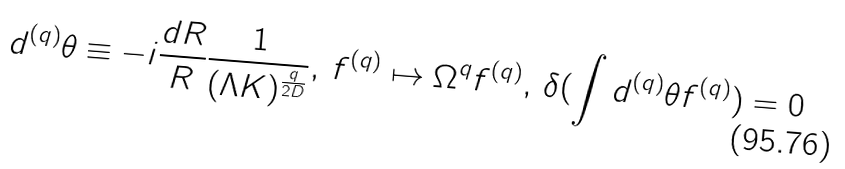Convert formula to latex. <formula><loc_0><loc_0><loc_500><loc_500>d ^ { ( q ) } \theta \equiv - i \frac { d R } { R } \frac { 1 } { ( \Lambda K ) ^ { \frac { q } { 2 D } } } , \, f ^ { ( q ) } \mapsto \Omega ^ { q } f ^ { ( q ) } , \, \delta ( \int d ^ { ( q ) } \theta f ^ { ( q ) } ) = 0</formula> 